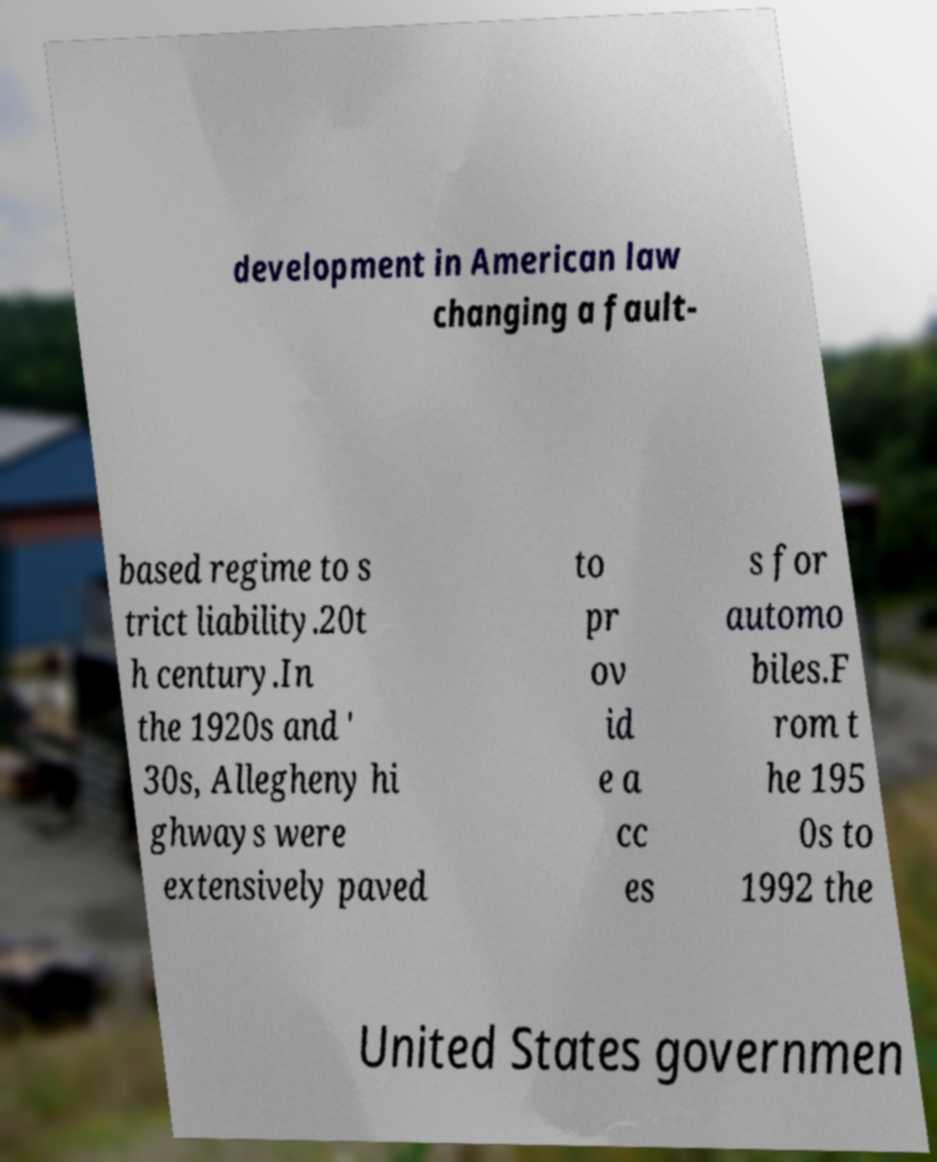There's text embedded in this image that I need extracted. Can you transcribe it verbatim? development in American law changing a fault- based regime to s trict liability.20t h century.In the 1920s and ' 30s, Allegheny hi ghways were extensively paved to pr ov id e a cc es s for automo biles.F rom t he 195 0s to 1992 the United States governmen 